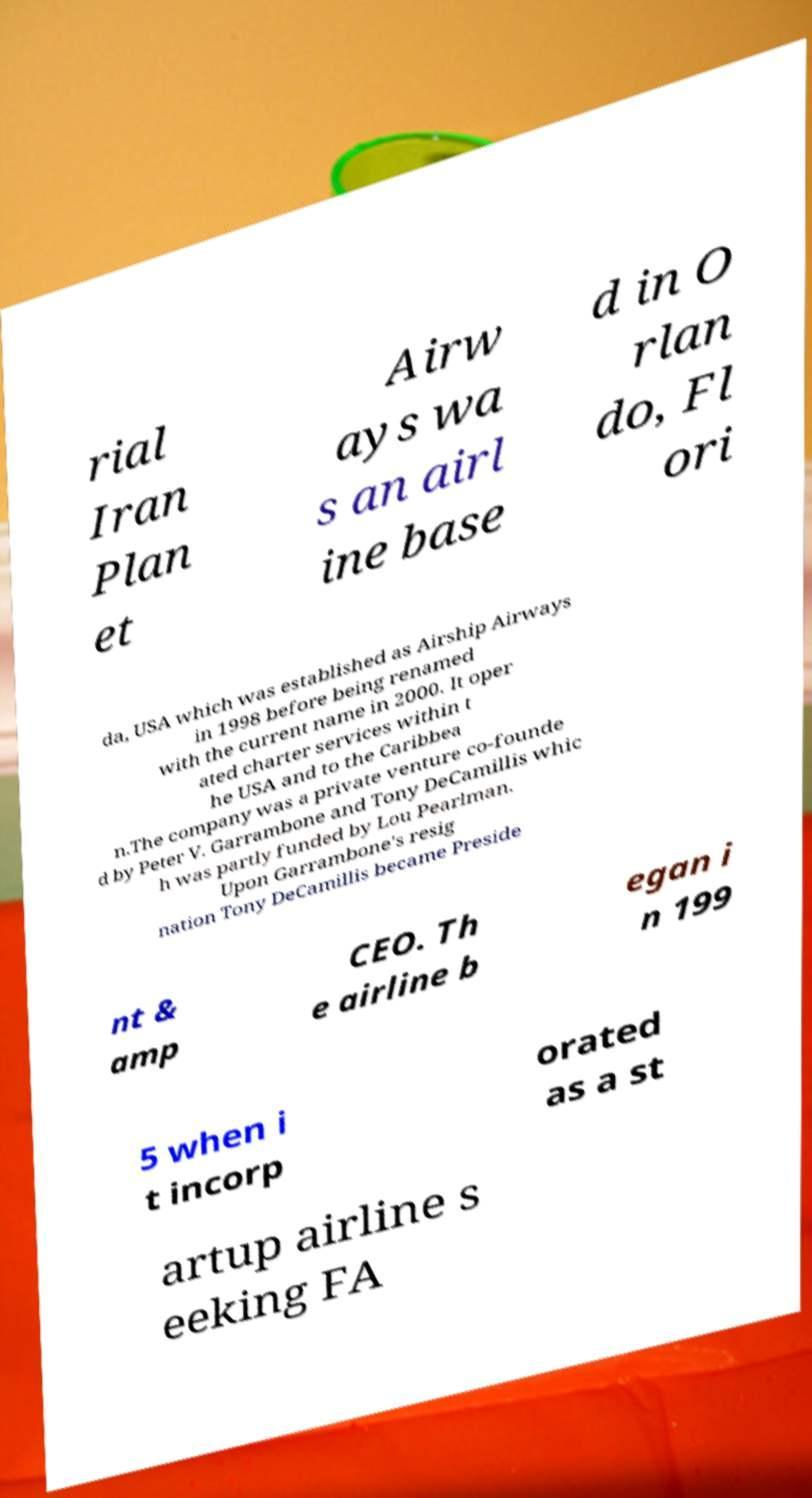Can you accurately transcribe the text from the provided image for me? rial Iran Plan et Airw ays wa s an airl ine base d in O rlan do, Fl ori da, USA which was established as Airship Airways in 1998 before being renamed with the current name in 2000. It oper ated charter services within t he USA and to the Caribbea n.The company was a private venture co-founde d by Peter V. Garrambone and Tony DeCamillis whic h was partly funded by Lou Pearlman. Upon Garrambone's resig nation Tony DeCamillis became Preside nt & amp CEO. Th e airline b egan i n 199 5 when i t incorp orated as a st artup airline s eeking FA 